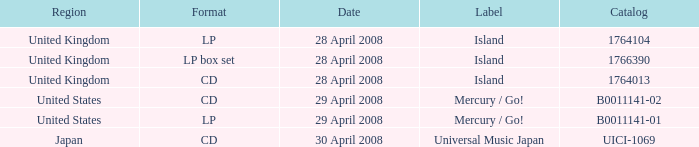What is the Label of the B0011141-01 Catalog? Mercury / Go!. 